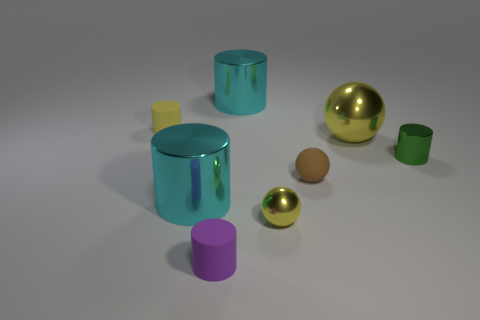What shape is the yellow object that is behind the small metallic cylinder and to the right of the yellow rubber thing?
Make the answer very short. Sphere. Is the number of matte things less than the number of green cylinders?
Provide a succinct answer. No. Are any red shiny cylinders visible?
Offer a terse response. No. What number of other objects are the same size as the yellow cylinder?
Keep it short and to the point. 4. Do the tiny yellow cylinder and the yellow sphere to the left of the brown rubber ball have the same material?
Ensure brevity in your answer.  No. Are there an equal number of big metal objects that are to the left of the purple thing and cyan things that are right of the small yellow metallic thing?
Provide a succinct answer. No. What is the material of the brown thing?
Provide a short and direct response. Rubber. There is another rubber cylinder that is the same size as the purple rubber cylinder; what color is it?
Give a very brief answer. Yellow. Are there any green things left of the big cyan metal cylinder that is in front of the green metallic object?
Keep it short and to the point. No. How many cylinders are big things or tiny green metallic things?
Provide a succinct answer. 3. 